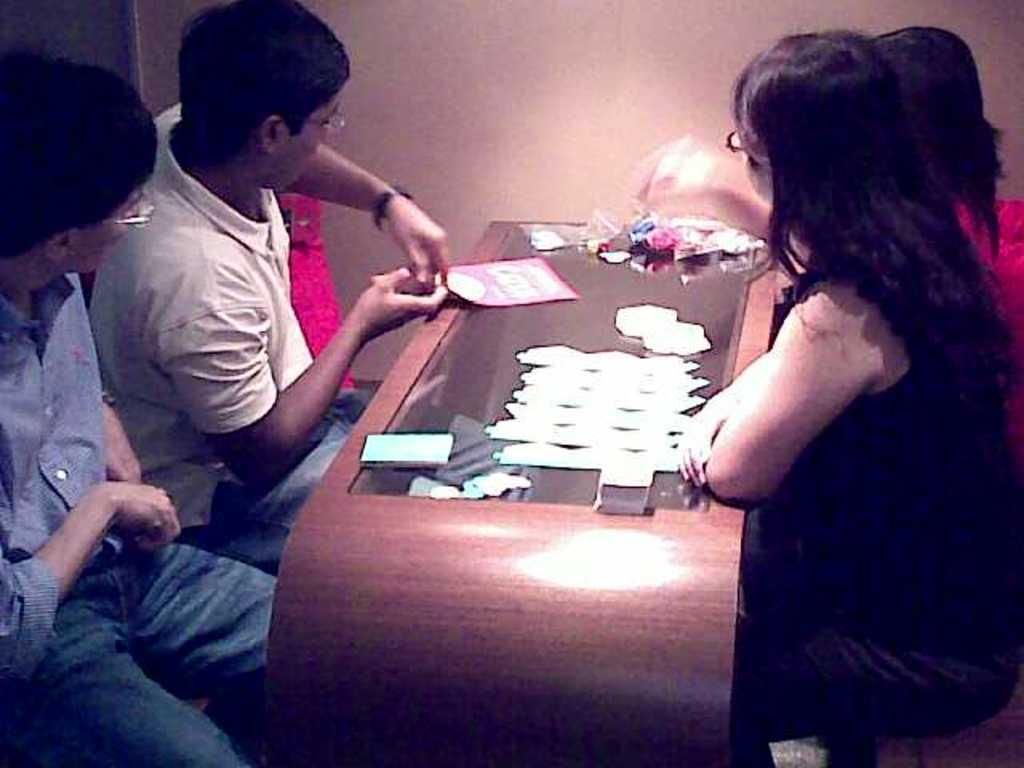What are the people in the image doing? The people in the image are sitting near a table. What is on the table in the image? There are some things on the table. What type of party is happening in the image? There is no indication of a party in the image; it simply shows people sitting near a table. What relation do the people sitting near the table have to each other? There is no information provided about the relationship between the people sitting near the table. 